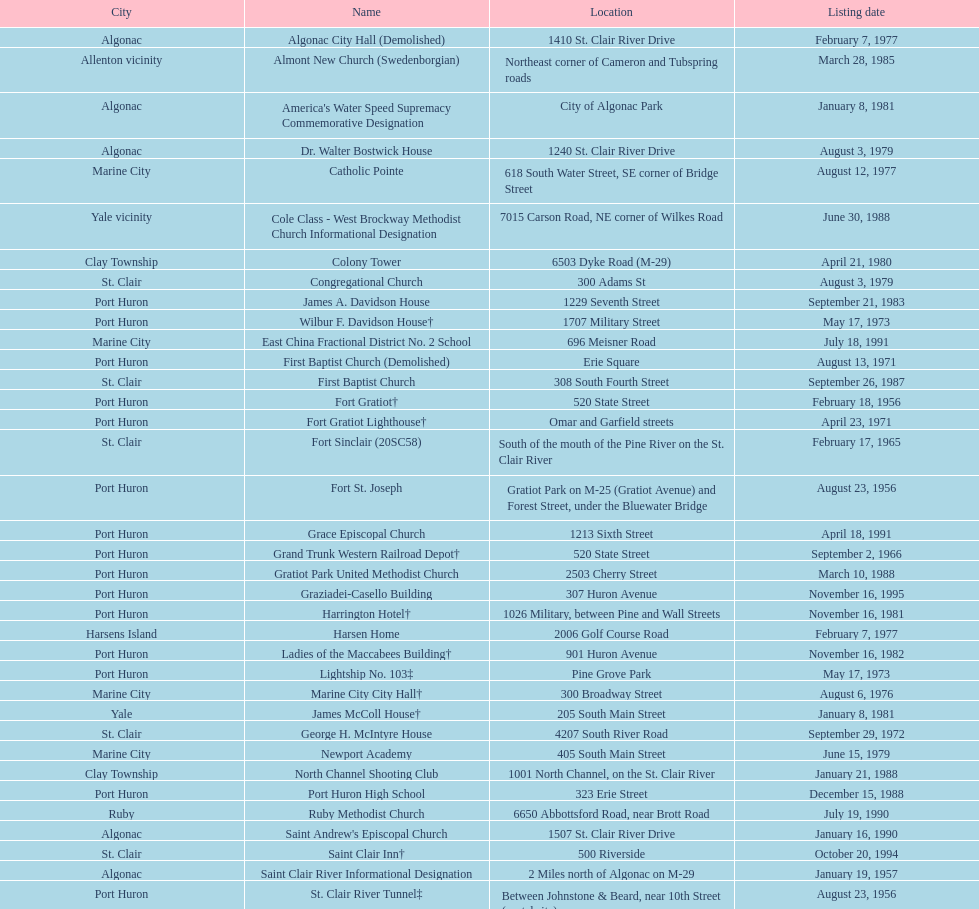Fort gratiot lighthouse and fort st. joseph are located in what city? Port Huron. 